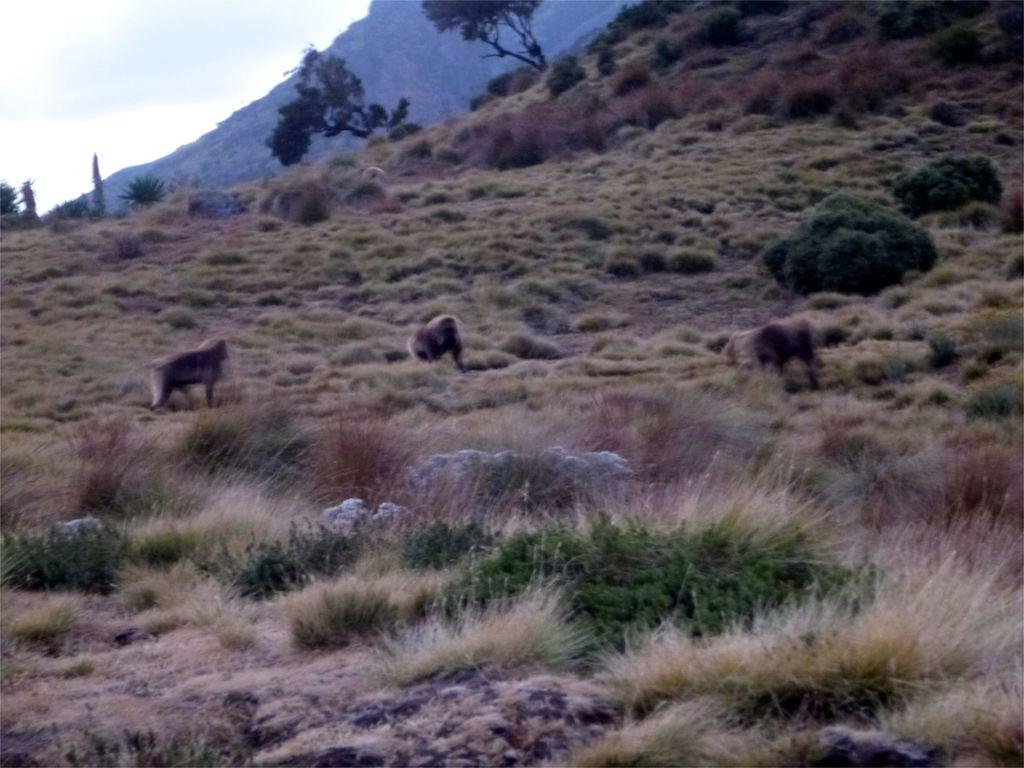How many monkeys are in the foreground of the image? There are three monkeys in the foreground of the image. What is the surface on which the monkeys are standing? The monkeys are on the grass. What type of natural features can be seen in the image? There are trees and mountains in the image. What part of the sky is visible in the image? The sky is visible in the top left of the image. What type of location might the image have been taken in? The image may have been taken near a hill station. What type of club can be seen in the image? There is no club present in the image; it features three monkeys on the grass with trees, mountains, and sky in the background. 